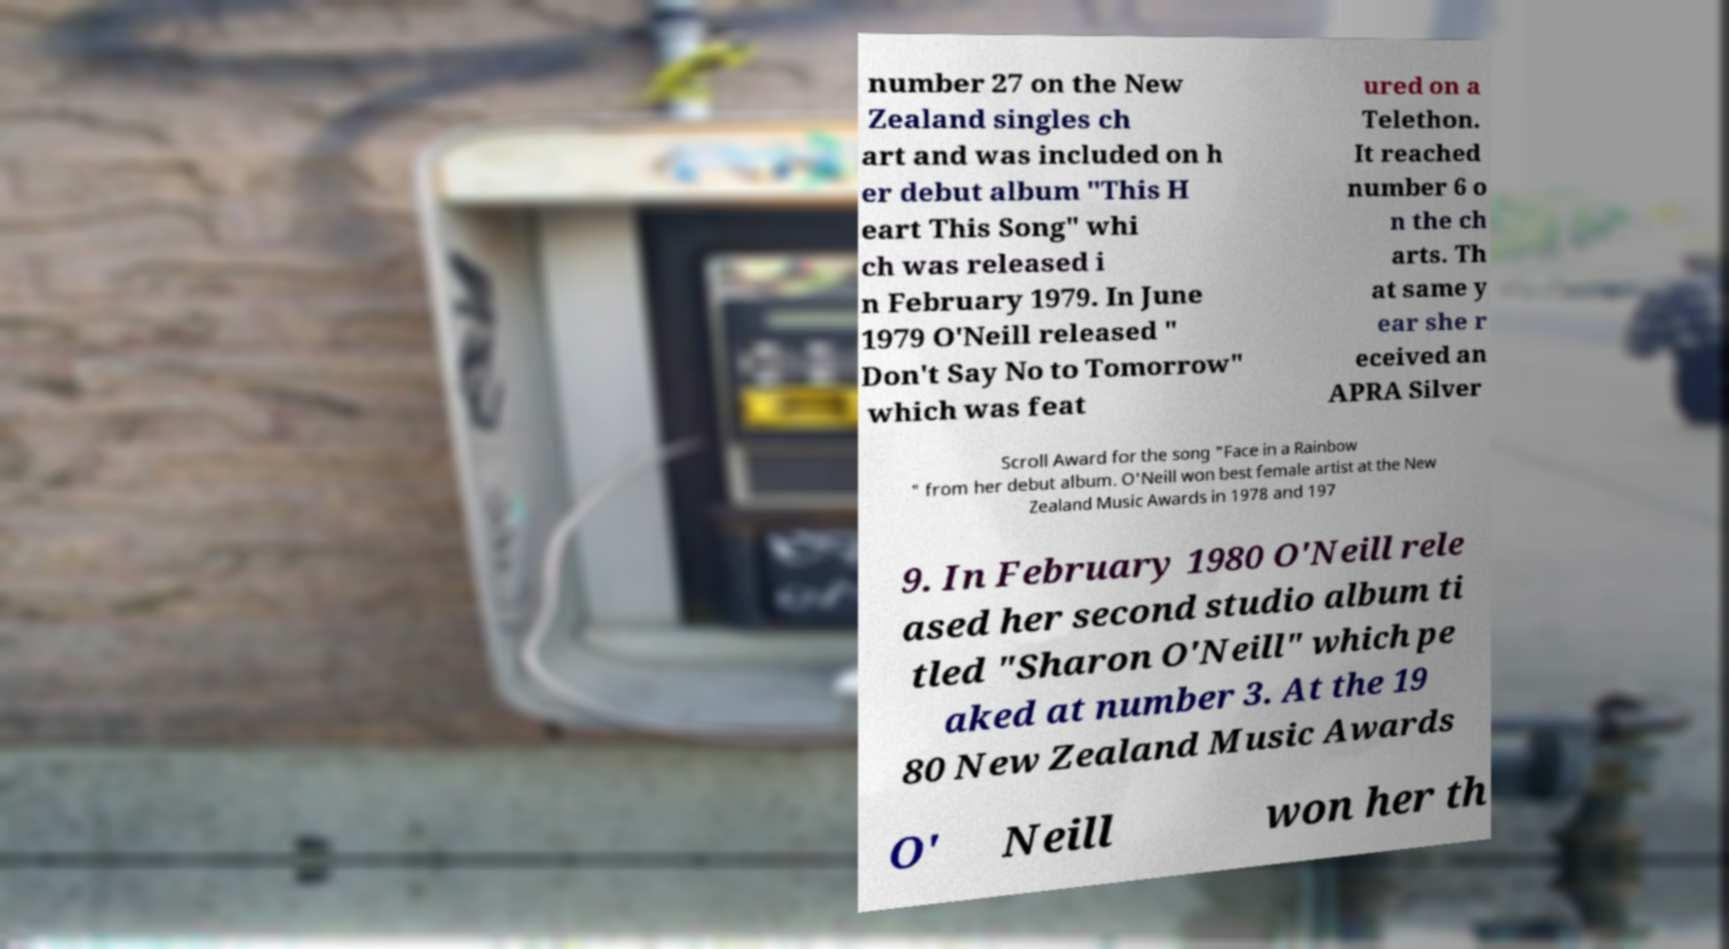Please identify and transcribe the text found in this image. number 27 on the New Zealand singles ch art and was included on h er debut album "This H eart This Song" whi ch was released i n February 1979. In June 1979 O'Neill released " Don't Say No to Tomorrow" which was feat ured on a Telethon. It reached number 6 o n the ch arts. Th at same y ear she r eceived an APRA Silver Scroll Award for the song "Face in a Rainbow " from her debut album. O'Neill won best female artist at the New Zealand Music Awards in 1978 and 197 9. In February 1980 O'Neill rele ased her second studio album ti tled "Sharon O'Neill" which pe aked at number 3. At the 19 80 New Zealand Music Awards O' Neill won her th 